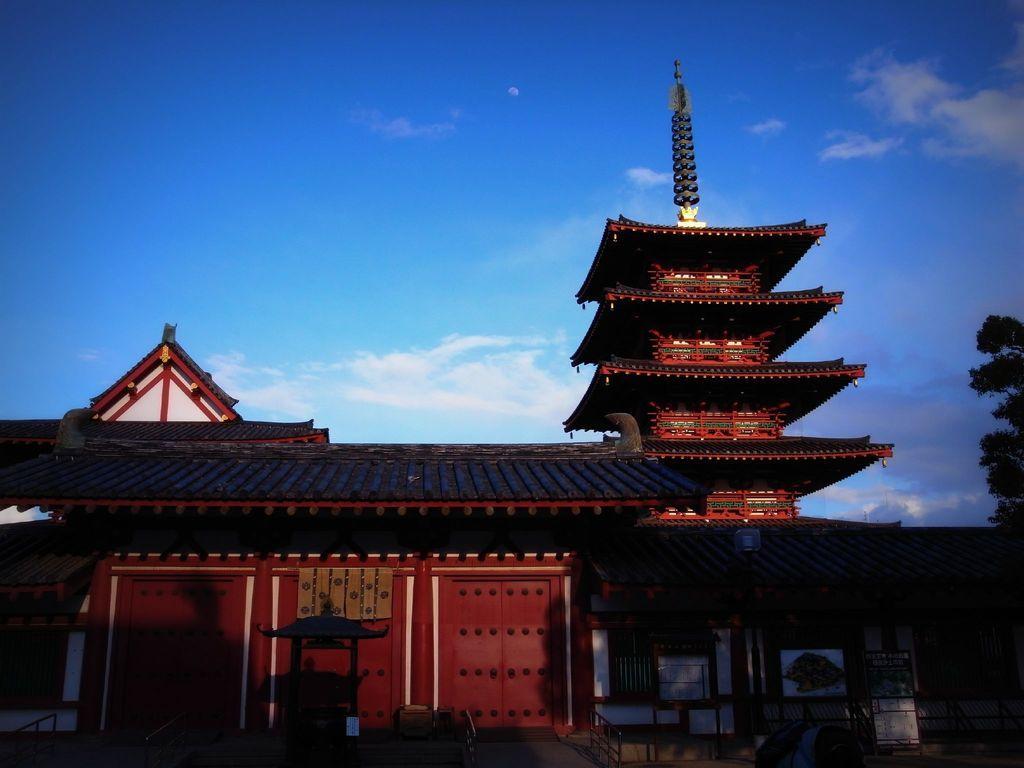Could you give a brief overview of what you see in this image? This is the picture of a house to which there are some thing at the top and it is in red and black color and to the side there is a tree. 